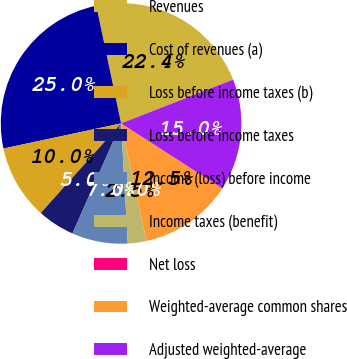Convert chart to OTSL. <chart><loc_0><loc_0><loc_500><loc_500><pie_chart><fcel>Revenues<fcel>Cost of revenues (a)<fcel>Loss before income taxes (b)<fcel>Loss before income taxes<fcel>Income (loss) before income<fcel>Income taxes (benefit)<fcel>Net loss<fcel>Weighted-average common shares<fcel>Adjusted weighted-average<nl><fcel>22.37%<fcel>25.04%<fcel>10.02%<fcel>5.01%<fcel>7.51%<fcel>2.5%<fcel>0.0%<fcel>12.52%<fcel>15.02%<nl></chart> 